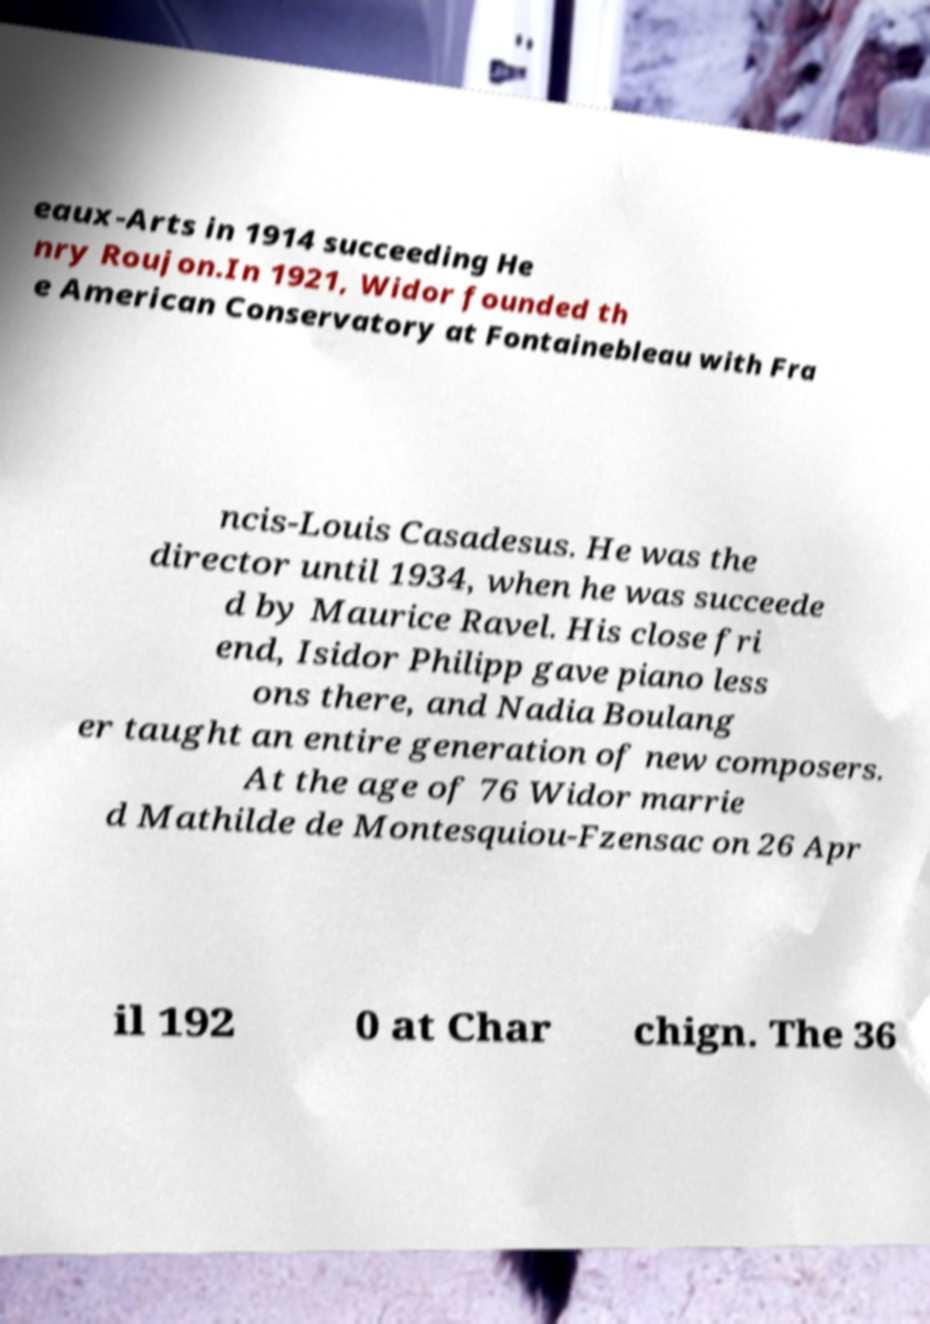Please identify and transcribe the text found in this image. eaux-Arts in 1914 succeeding He nry Roujon.In 1921, Widor founded th e American Conservatory at Fontainebleau with Fra ncis-Louis Casadesus. He was the director until 1934, when he was succeede d by Maurice Ravel. His close fri end, Isidor Philipp gave piano less ons there, and Nadia Boulang er taught an entire generation of new composers. At the age of 76 Widor marrie d Mathilde de Montesquiou-Fzensac on 26 Apr il 192 0 at Char chign. The 36 